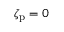<formula> <loc_0><loc_0><loc_500><loc_500>\zeta _ { p } = 0</formula> 